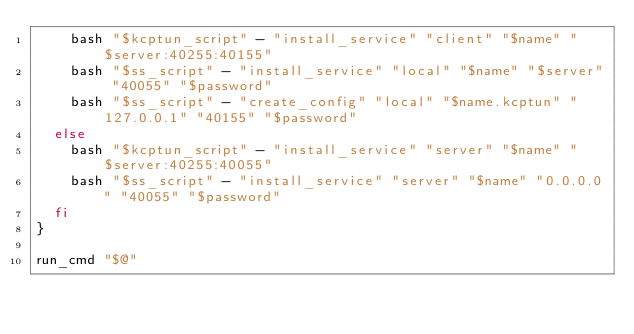<code> <loc_0><loc_0><loc_500><loc_500><_Bash_>    bash "$kcptun_script" - "install_service" "client" "$name" "$server:40255:40155"
    bash "$ss_script" - "install_service" "local" "$name" "$server" "40055" "$password"
    bash "$ss_script" - "create_config" "local" "$name.kcptun" "127.0.0.1" "40155" "$password"
  else
    bash "$kcptun_script" - "install_service" "server" "$name" "$server:40255:40055"
    bash "$ss_script" - "install_service" "server" "$name" "0.0.0.0" "40055" "$password"
  fi
}

run_cmd "$@"

</code> 